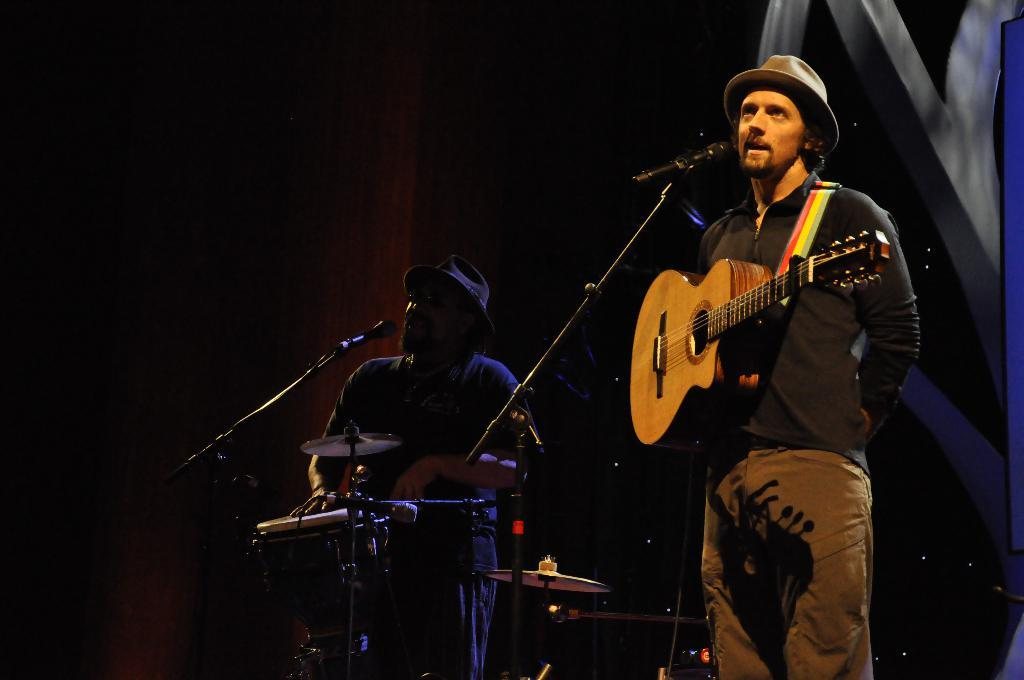What is the person at the right side of the image holding? The person at the right side of the image is holding a guitar. What is the person in the middle of the image doing? The person in the middle of the image is playing drums. What objects are present at the front of the image? There are microphones at the front of the image. How many people can be seen in the image? There are two people visible in the image. Can you see a river flowing in the background of the image? No, there is no river visible in the image. Is the person at the right side of the image reading a book? No, the person at the right side of the image is holding a guitar, not a book. 